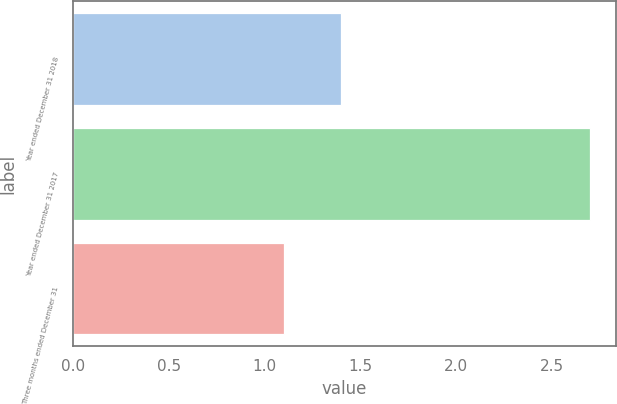<chart> <loc_0><loc_0><loc_500><loc_500><bar_chart><fcel>Year ended December 31 2018<fcel>Year ended December 31 2017<fcel>Three months ended December 31<nl><fcel>1.4<fcel>2.7<fcel>1.1<nl></chart> 